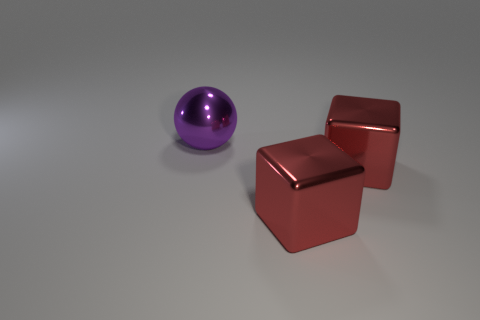Add 2 large purple shiny objects. How many objects exist? 5 Subtract all balls. How many objects are left? 2 Subtract all purple matte cylinders. Subtract all big things. How many objects are left? 0 Add 3 red metal things. How many red metal things are left? 5 Add 1 metal cubes. How many metal cubes exist? 3 Subtract 1 purple balls. How many objects are left? 2 